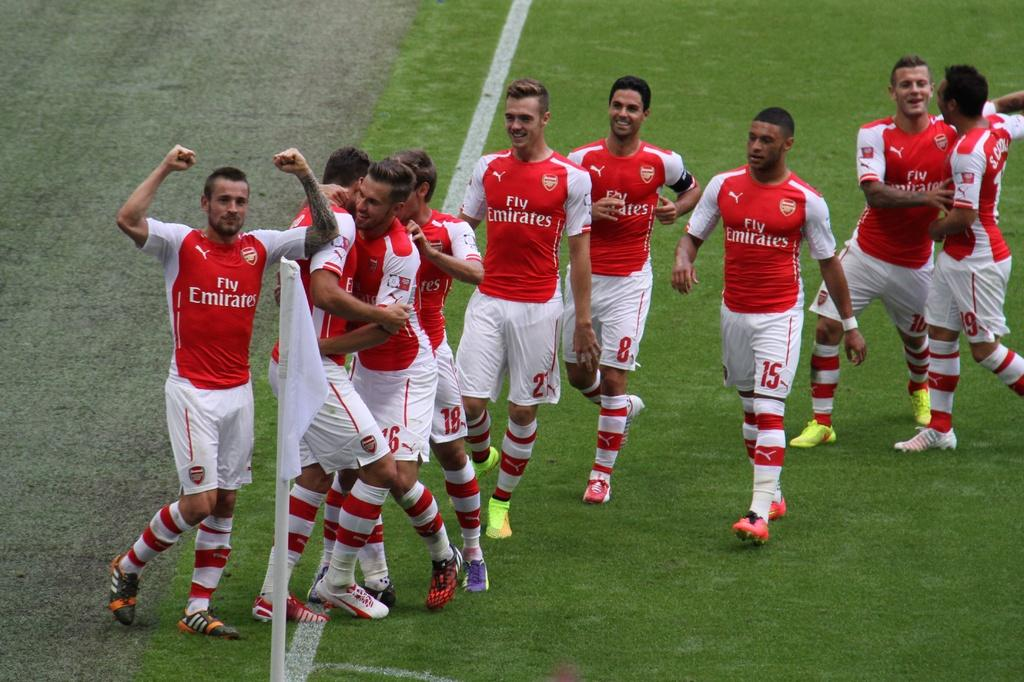What is the main subject of the image? The main subject of the image is a group of people. What are the people wearing in the image? The people are wearing dresses in the image. Where are the people standing in the image? The people are standing on the ground in the image. What can be seen in the foreground of the image? There is a flag on a pole in the foreground of the image. What type of stitch is used to hold the flag together in the image? There is no information about the type of stitch used to hold the flag together in the image. 